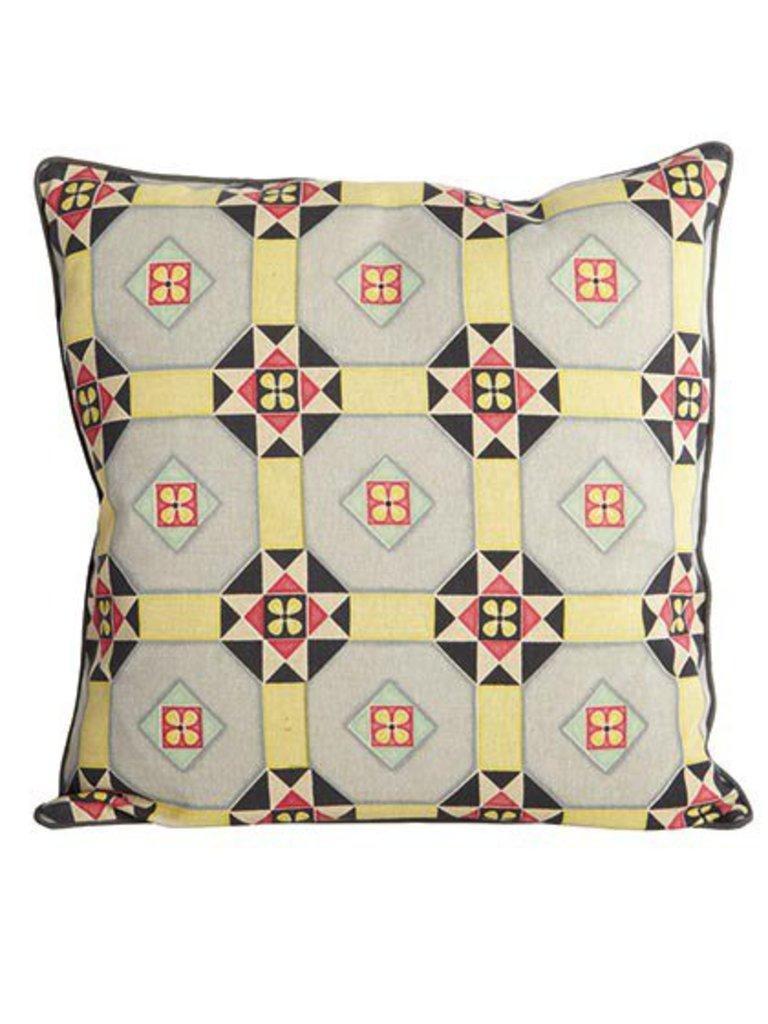Please provide a concise description of this image. In this picture there is a pillow which has few designs on it. 